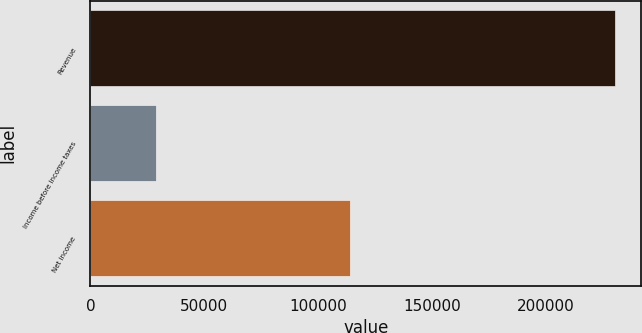Convert chart. <chart><loc_0><loc_0><loc_500><loc_500><bar_chart><fcel>Revenue<fcel>Income before income taxes<fcel>Net income<nl><fcel>230323<fcel>28871<fcel>113794<nl></chart> 